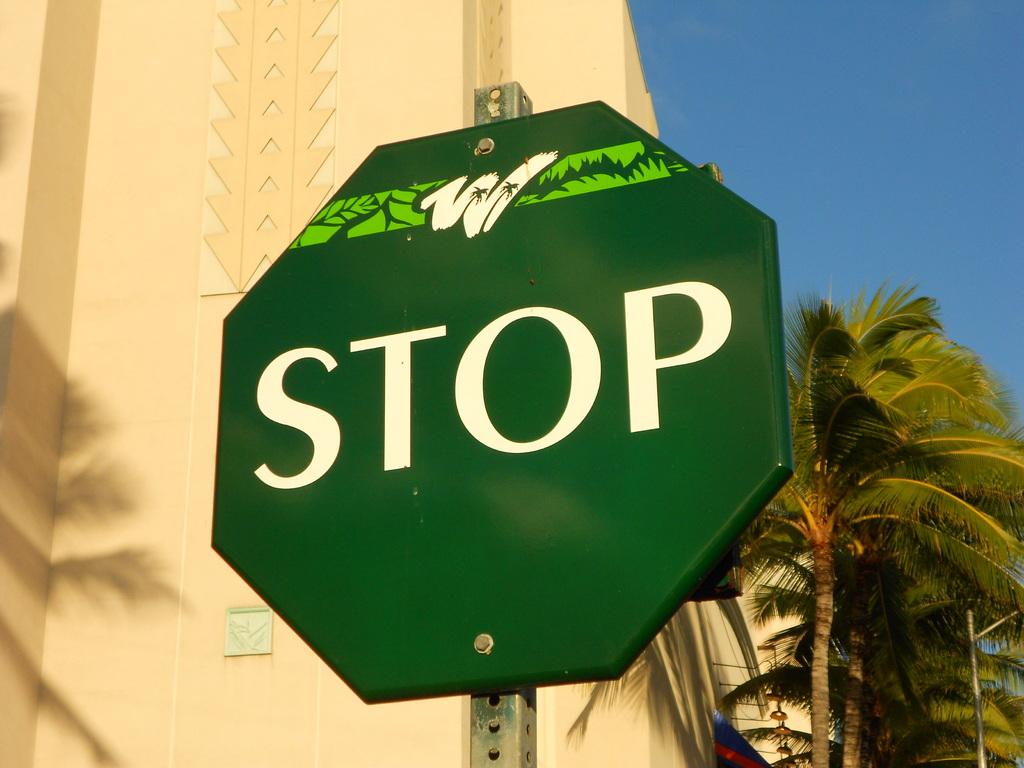What does the sign say?
Ensure brevity in your answer.  Stop. 